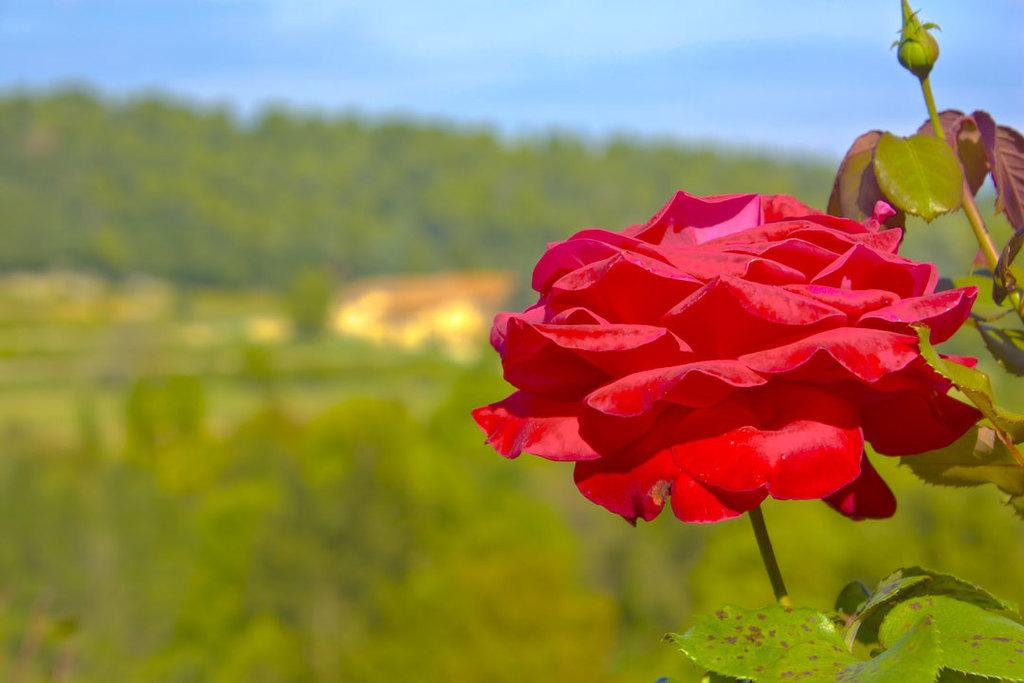What is the main subject of the image? There is a flower in the image. What color is the flower? The flower is red in color. What else can be seen in the image besides the flower? There are leaves in the image. What is visible in the background of the image? The sky is visible in the image. How is the background of the image depicted? The background is blurred. Can you tell me how many knees are visible in the image? There are no knees visible in the image, as it features a flower with leaves and a blurred background}. 